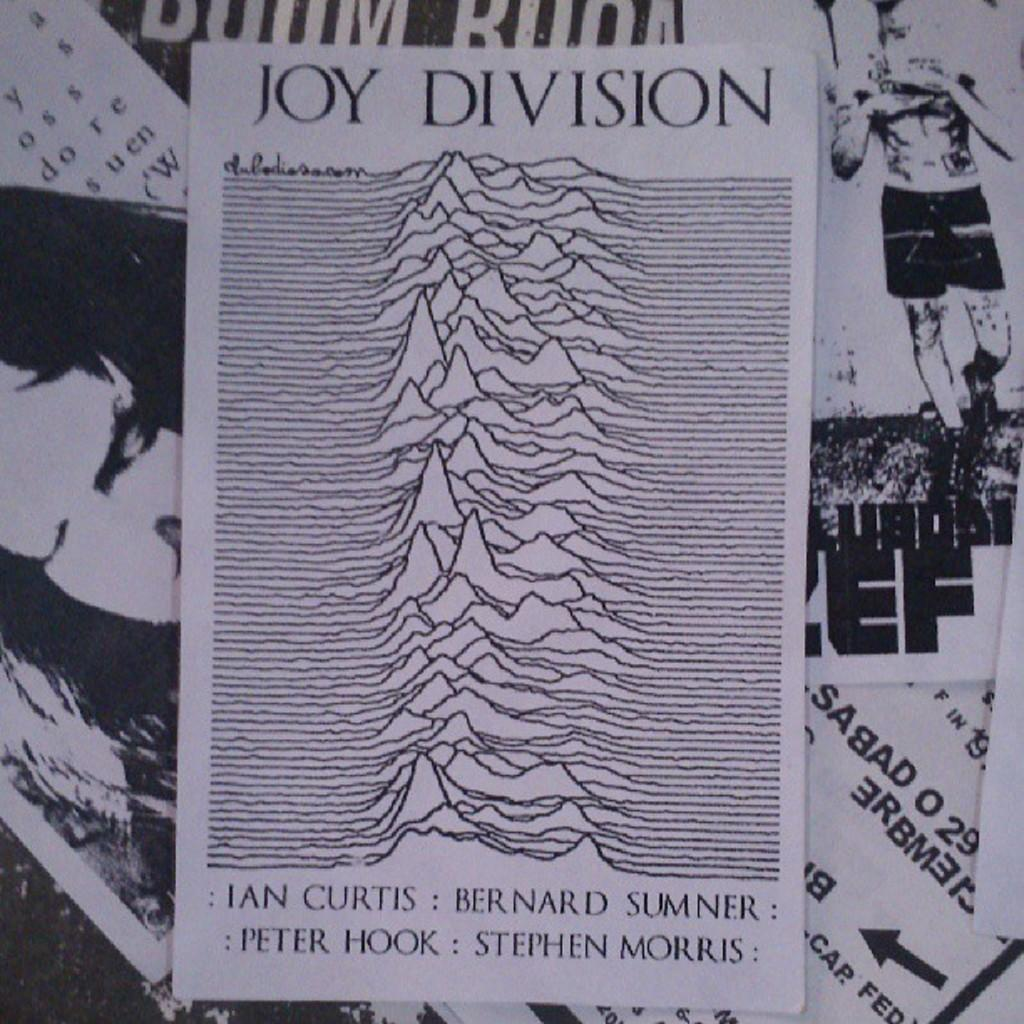<image>
Present a compact description of the photo's key features. White piece of paper saying Joy Division by Peter Hook and Stephen Morris. 